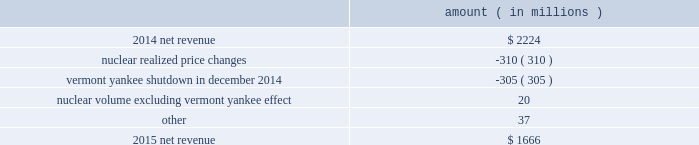Entergy corporation and subsidiaries management 2019s financial discussion and analysis the miso deferral variance is primarily due to the deferral in 2014 of non-fuel miso-related charges , as approved by the lpsc and the mpsc .
The deferral of non-fuel miso-related charges is partially offset in other operation and maintenance expenses .
See note 2 to the financial statements for further discussion of the recovery of non-fuel miso-related charges .
The waterford 3 replacement steam generator provision is due to a regulatory charge of approximately $ 32 million recorded in 2015 related to the uncertainty associated with the resolution of the waterford 3 replacement steam generator project .
See note 2 to the financial statements for a discussion of the waterford 3 replacement steam generator prudence review proceeding .
Entergy wholesale commodities following is an analysis of the change in net revenue comparing 2015 to 2014 .
Amount ( in millions ) .
As shown in the table above , net revenue for entergy wholesale commodities decreased by approximately $ 558 million in 2015 primarily due to : 2022 lower realized wholesale energy prices , primarily due to significantly higher northeast market power prices in 2014 , and lower capacity prices in 2015 ; and 2022 a decrease in net revenue as a result of vermont yankee ceasing power production in december 2014 .
The decrease was partially offset by higher volume in the entergy wholesale commodities nuclear fleet , excluding vermont yankee , resulting from fewer refueling outage days in 2015 as compared to 2014 , partially offset by more unplanned outage days in 2015 as compared to 2014. .
What was the percent of the decline in the net revenue in 2015? 
Computations: (1666 - 2224)
Answer: -558.0. 